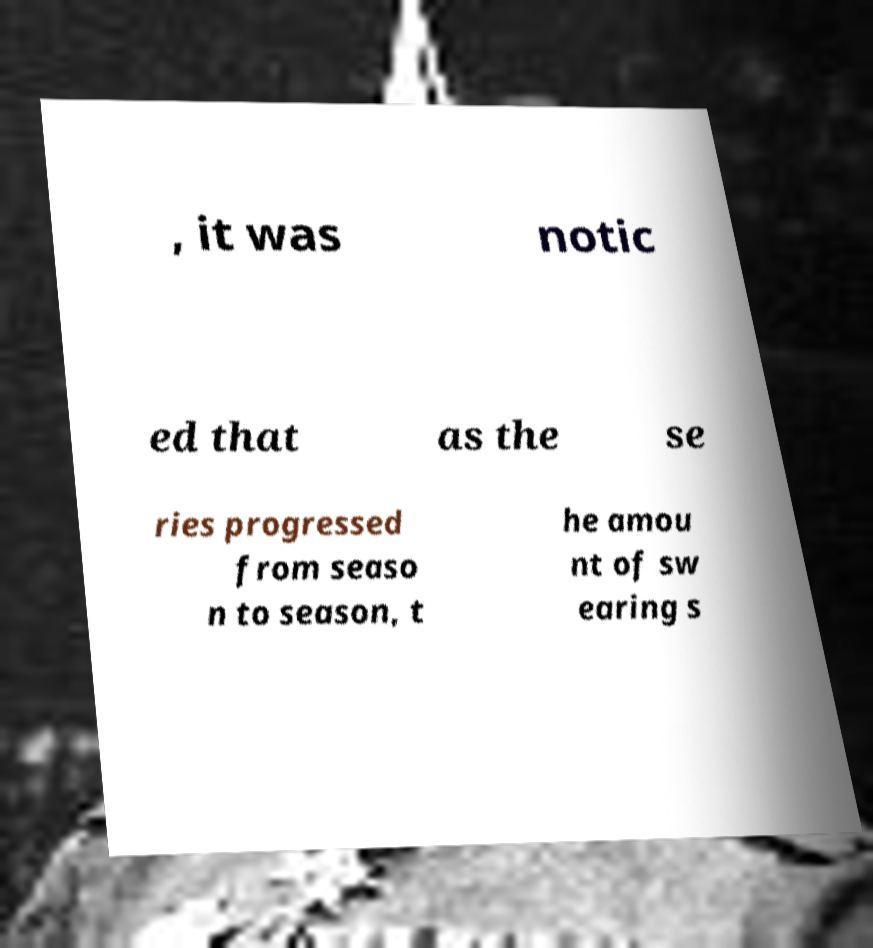Could you extract and type out the text from this image? , it was notic ed that as the se ries progressed from seaso n to season, t he amou nt of sw earing s 